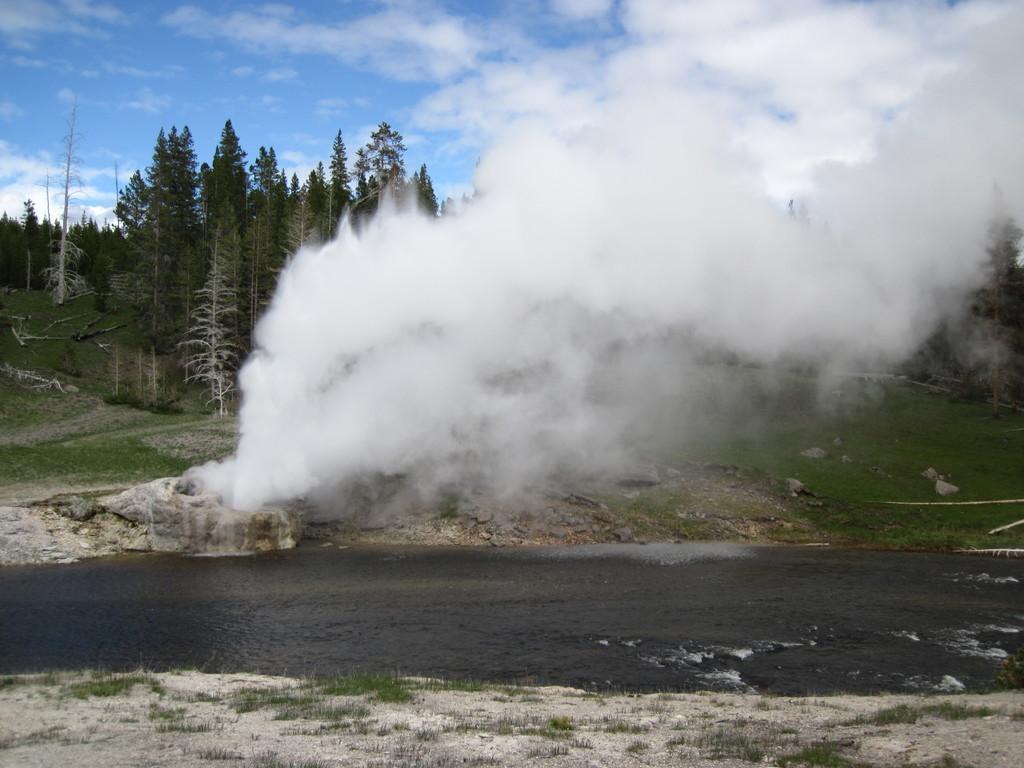Describe this image in one or two sentences. In this image, I can see water, smoke and trees on a hill. In the background, there is the sky. 